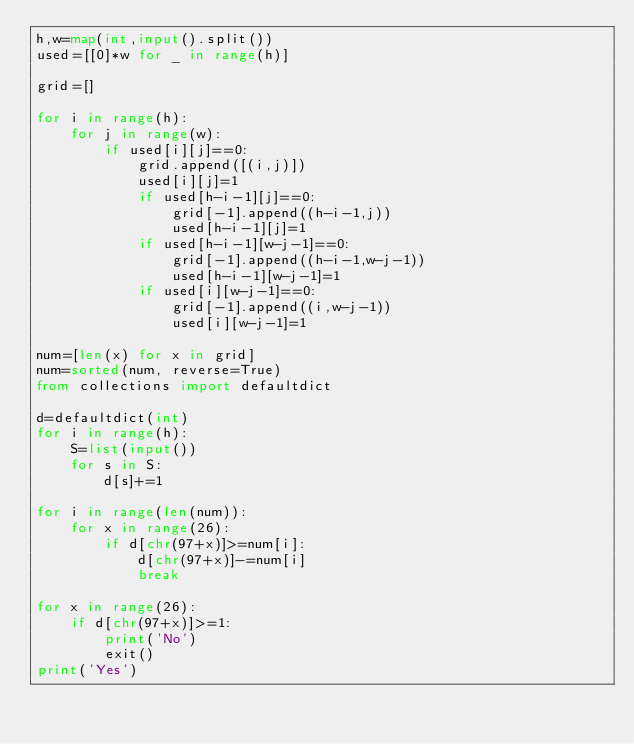Convert code to text. <code><loc_0><loc_0><loc_500><loc_500><_Python_>h,w=map(int,input().split())
used=[[0]*w for _ in range(h)]

grid=[]

for i in range(h):
    for j in range(w):
        if used[i][j]==0:
            grid.append([(i,j)])
            used[i][j]=1
            if used[h-i-1][j]==0:
                grid[-1].append((h-i-1,j))
                used[h-i-1][j]=1
            if used[h-i-1][w-j-1]==0:
                grid[-1].append((h-i-1,w-j-1))
                used[h-i-1][w-j-1]=1
            if used[i][w-j-1]==0:
                grid[-1].append((i,w-j-1))
                used[i][w-j-1]=1

num=[len(x) for x in grid]
num=sorted(num, reverse=True)
from collections import defaultdict

d=defaultdict(int)
for i in range(h):
    S=list(input())
    for s in S:
        d[s]+=1

for i in range(len(num)):
    for x in range(26):
        if d[chr(97+x)]>=num[i]:
            d[chr(97+x)]-=num[i]
            break

for x in range(26):
    if d[chr(97+x)]>=1:
        print('No')
        exit()
print('Yes')</code> 